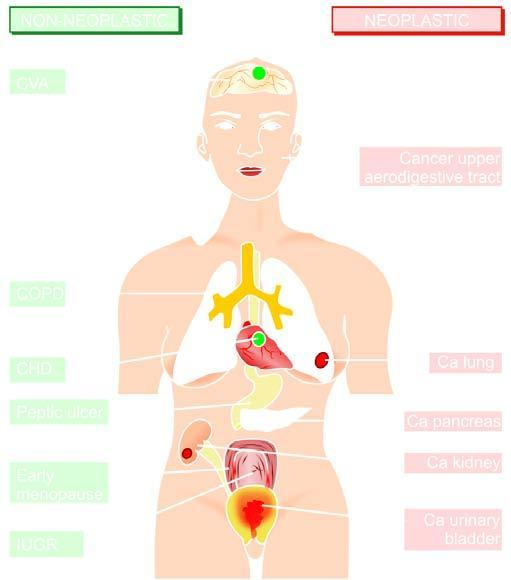does the affected part indicate non-neoplastic diseases associated with smoking?
Answer the question using a single word or phrase. No 